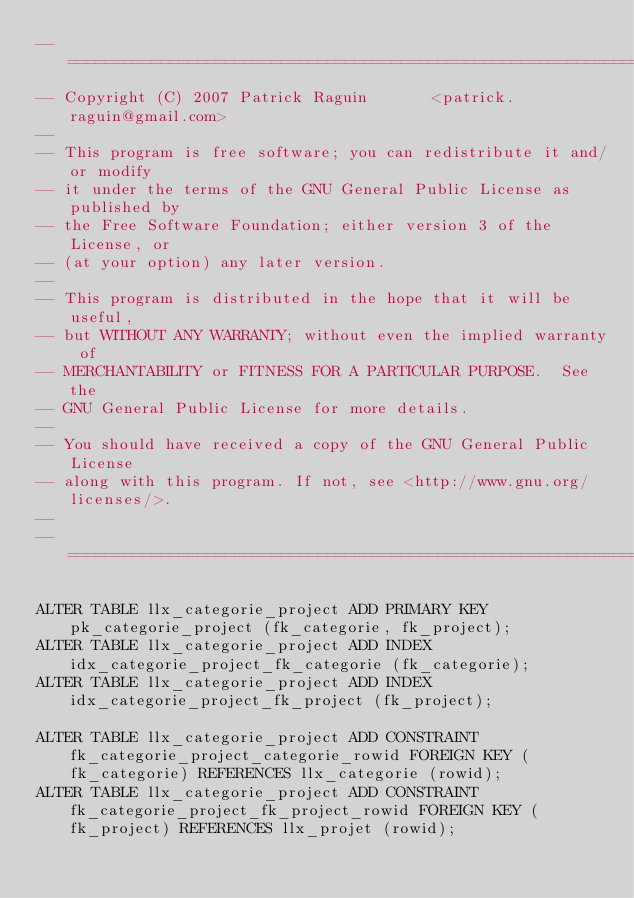<code> <loc_0><loc_0><loc_500><loc_500><_SQL_>-- ============================================================================
-- Copyright (C) 2007 Patrick Raguin       <patrick.raguin@gmail.com>
--
-- This program is free software; you can redistribute it and/or modify
-- it under the terms of the GNU General Public License as published by
-- the Free Software Foundation; either version 3 of the License, or
-- (at your option) any later version.
--
-- This program is distributed in the hope that it will be useful,
-- but WITHOUT ANY WARRANTY; without even the implied warranty of
-- MERCHANTABILITY or FITNESS FOR A PARTICULAR PURPOSE.  See the
-- GNU General Public License for more details.
--
-- You should have received a copy of the GNU General Public License
-- along with this program. If not, see <http://www.gnu.org/licenses/>.
--
-- ============================================================================

ALTER TABLE llx_categorie_project ADD PRIMARY KEY pk_categorie_project (fk_categorie, fk_project);
ALTER TABLE llx_categorie_project ADD INDEX idx_categorie_project_fk_categorie (fk_categorie);
ALTER TABLE llx_categorie_project ADD INDEX idx_categorie_project_fk_project (fk_project);

ALTER TABLE llx_categorie_project ADD CONSTRAINT fk_categorie_project_categorie_rowid FOREIGN KEY (fk_categorie) REFERENCES llx_categorie (rowid);
ALTER TABLE llx_categorie_project ADD CONSTRAINT fk_categorie_project_fk_project_rowid FOREIGN KEY (fk_project) REFERENCES llx_projet (rowid);
</code> 